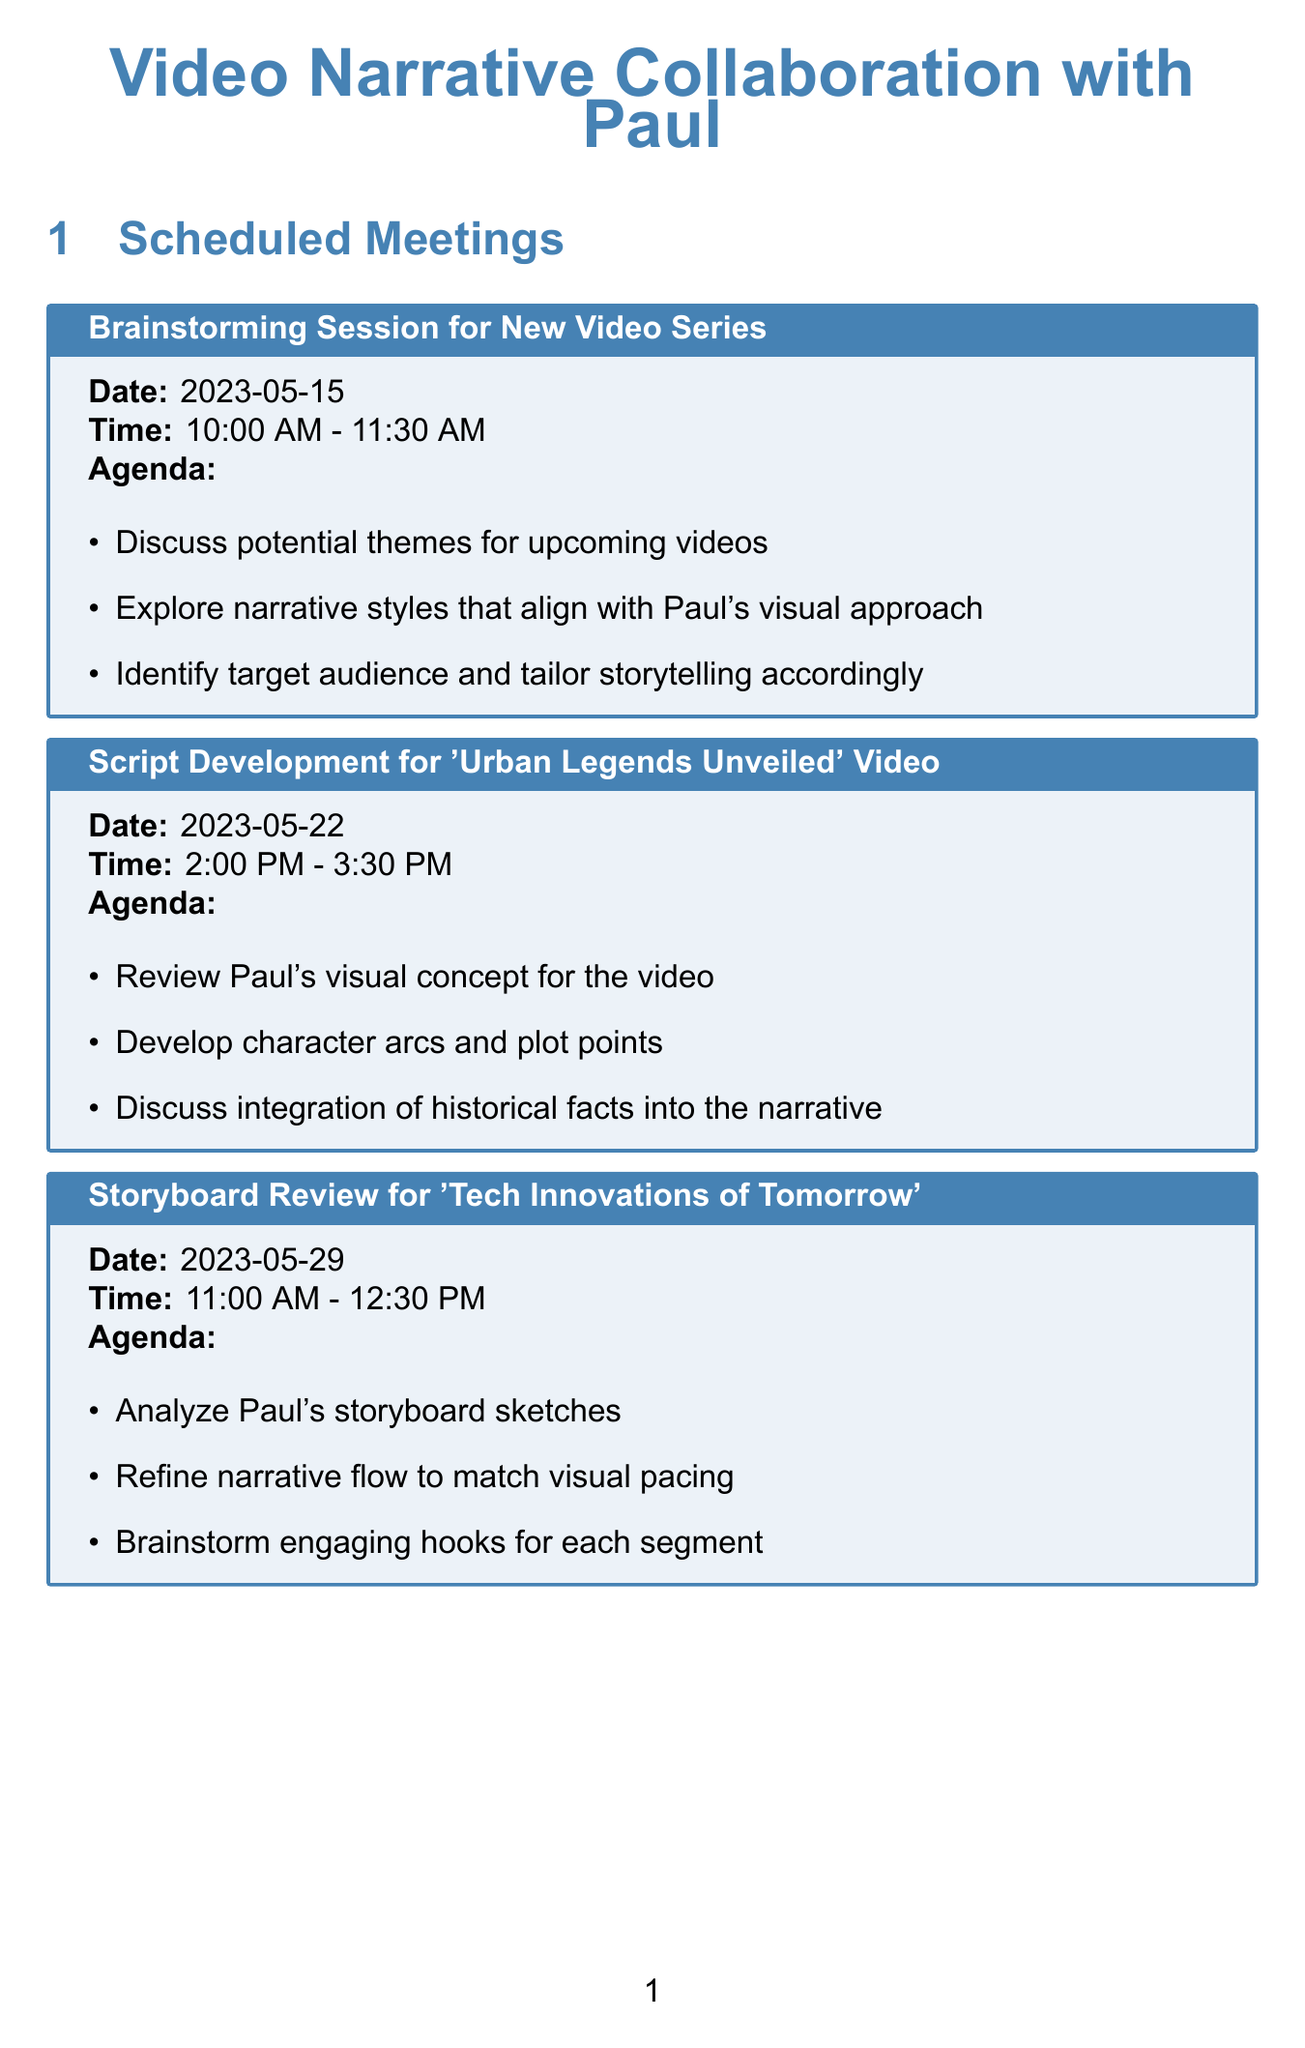What is the date of the brainstorming session? The date of the brainstorming session is specified in the schedule under "scheduled meetings."
Answer: 2023-05-15 What time is the feedback session on 'Culinary Adventures' Pilot? The time for the feedback session is listed in the scheduled meetings section.
Answer: 3:00 PM - 4:30 PM What is the project deadline for 'Urban Legends Unveiled'? The project deadline is mentioned in the project deadlines section, specifically for that project.
Answer: 2023-06-02 Which collaboration tool is used for video conferencing? The document lists various collaboration tools, and this tool is mentioned.
Answer: Zoom What narrative style is suggested for the Urban Legends series? This question requires understanding the narrative style guidelines, specifically related to one series.
Answer: Suspense and reveal How many meetings are scheduled before June 2023? This question involves counting the entries in the "scheduled meetings" section that occur before June.
Answer: Four What is the main topic of the meeting on May 22? This topic is outlined in the “scheduled meetings” section where meetings are titled.
Answer: Script Development for 'Urban Legends Unveiled' Video What is the tool used for collaborative script writing? The document specifies various tools and their purposes, including this one.
Answer: Google Docs What is the premiere date for the 'Tech Innovations of Tomorrow' video? The premiere date is clearly stated in the project deadlines section for that video.
Answer: 2023-07-15 